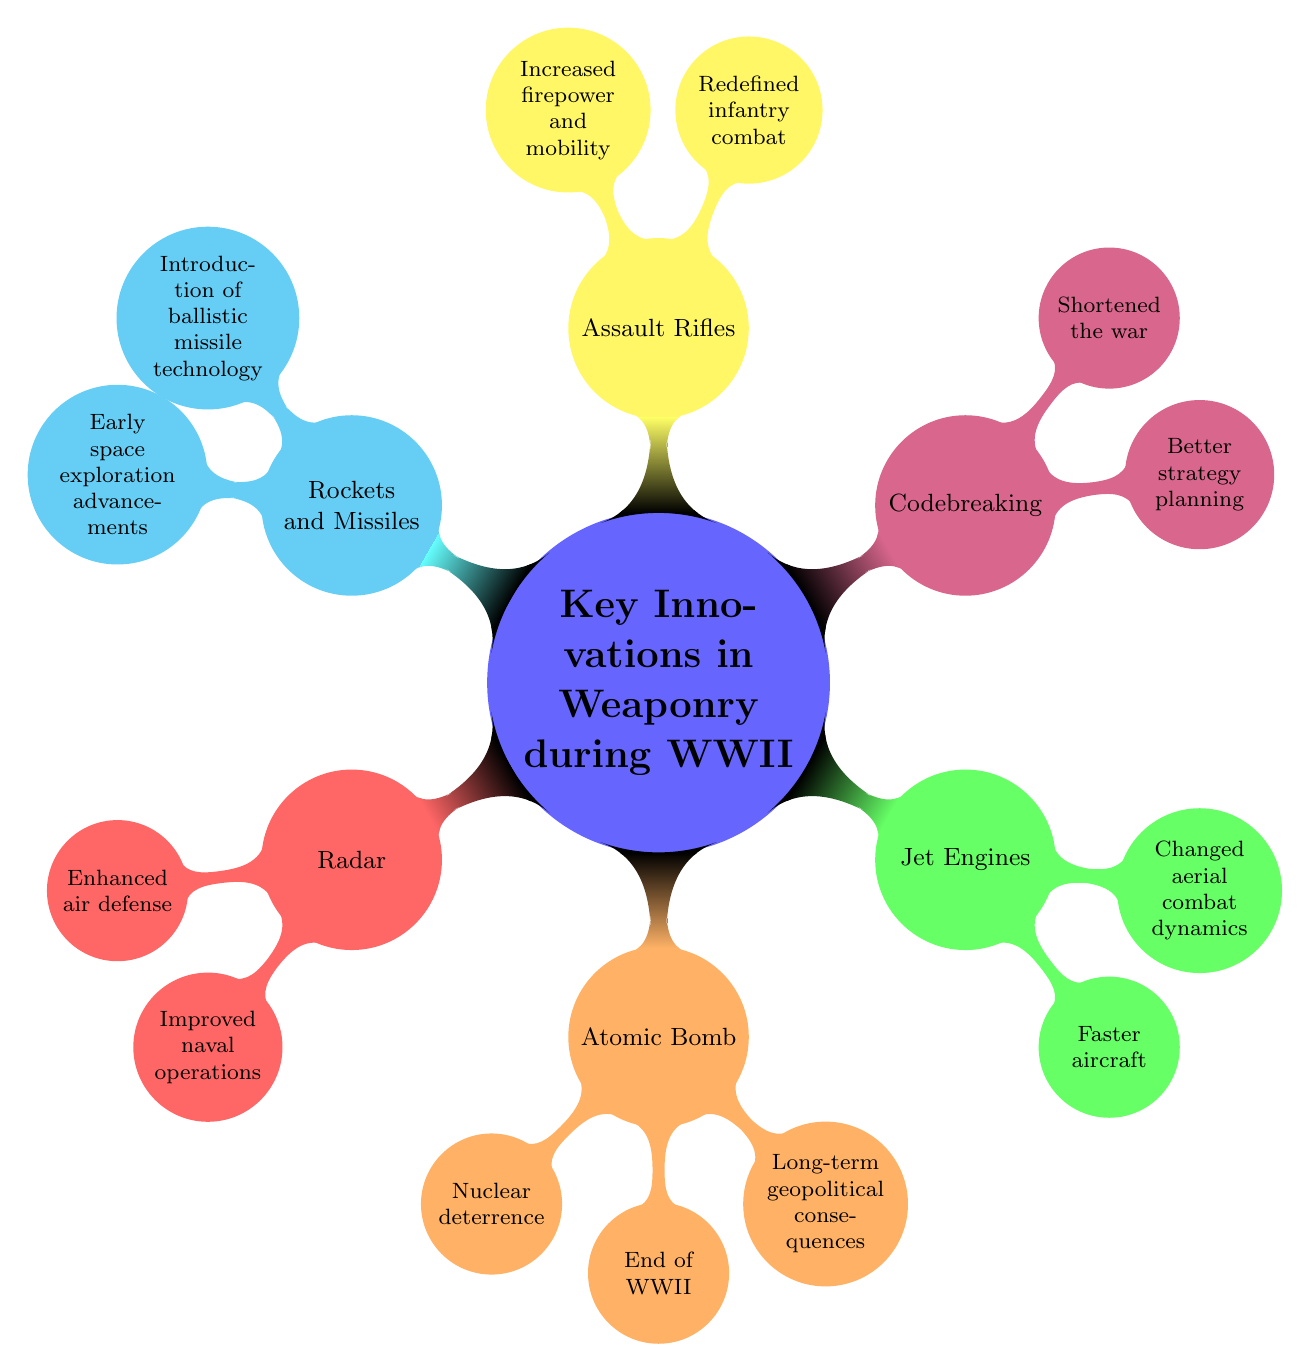What is one of the impacts of Jet Engines? According to the diagram under the Jet Engines node, one of the impacts listed is that they led to faster aircraft.
Answer: Faster aircraft How many innovations in weaponry are listed in the diagram? The diagram shows a total of six innovations in weaponry branching from the main topic, counting each node that represents an innovation.
Answer: Six What is a key example of Codebreaking technology used during WWII? The diagram specifies the Enigma machine as a key example under the Codebreaking node, which illustrates its significance during the war.
Answer: Enigma machine Which innovation is associated with "Nuclear deterrence"? The Atomic Bomb node includes 'Nuclear deterrence' as one of its impacts; thus, this innovation is explicitly associated with that term.
Answer: Atomic Bomb What term describes the impact of Assault Rifles on infantry combat? The diagram states that Assault Rifles redefined infantry combat, indicating a significant transformation in this area due to their introduction.
Answer: Redefined infantry combat What was a consequence of the Atomic Bomb related to international relations? The diagram highlights that one of the long-term geopolitical consequences of the Atomic Bomb was its role in shaping global power dynamics post-WWII, which affects international relations.
Answer: Long-term geopolitical consequences Which innovation led to the introduction of ballistic missile technology? The Rockets and Missiles node mentions the V-2 rocket, which is described as the innovation that introduced ballistic missile technology, indicating its historical significance.
Answer: V-2 rocket What combined impact resulted from advancements in Radar? The Radar node specifies two impacts: enhanced air defense and improved naval operations. Together, these impacts contributed to overall military capabilities during WWII.
Answer: Enhanced air defense and Improved naval operations How did Codebreaking influence the duration of WWII? The Codebreaking innovations, specifically noted in the diagram, were crucial for better strategy planning and contributed to shortening the war, indicating a direct link between these technologies and the conflict's duration.
Answer: Shortened the war 